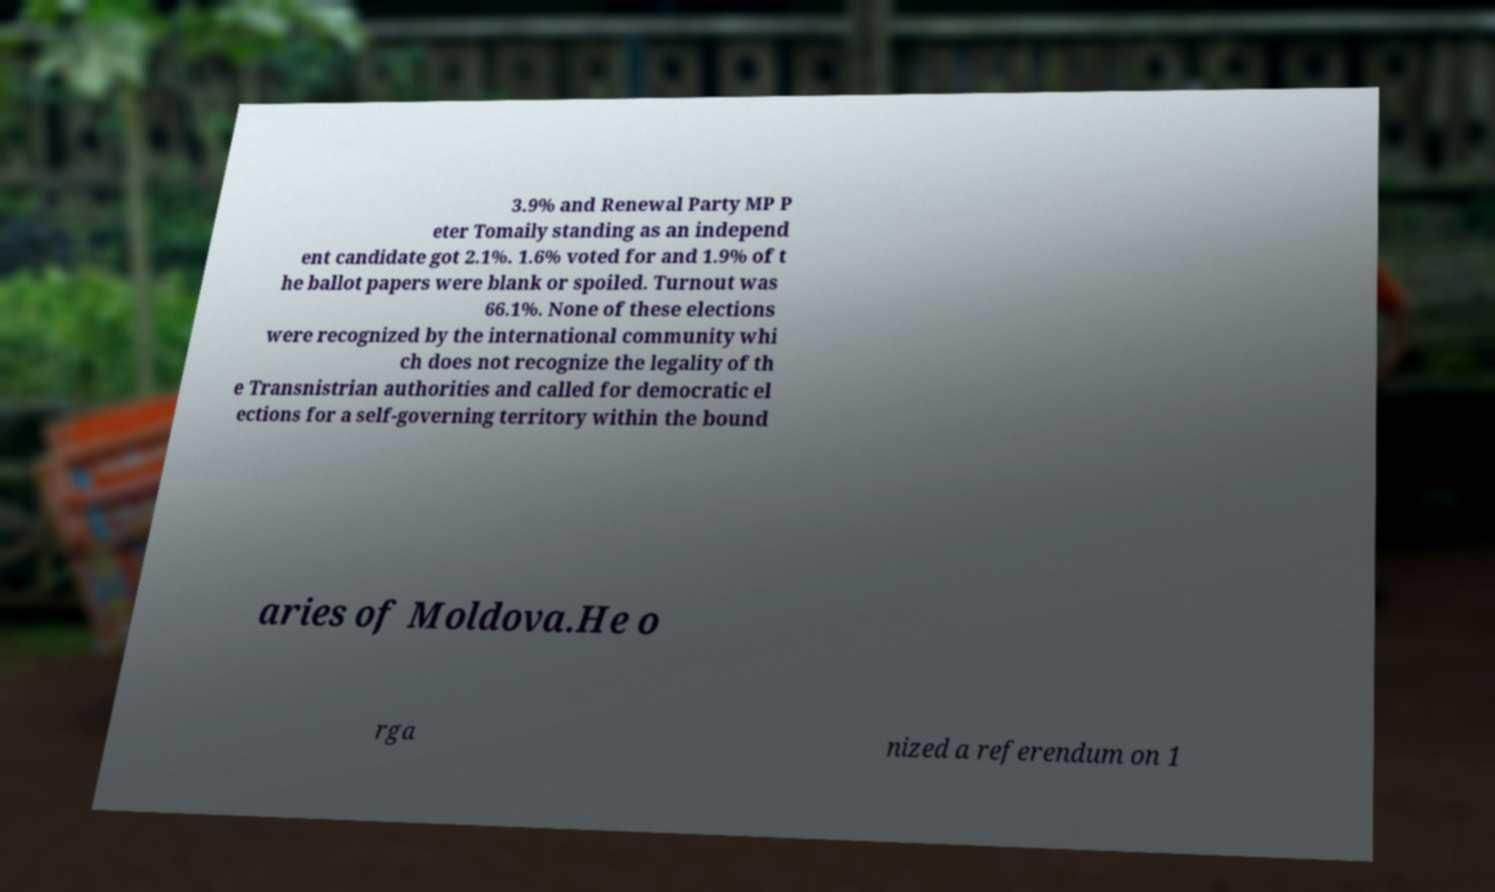Can you accurately transcribe the text from the provided image for me? 3.9% and Renewal Party MP P eter Tomaily standing as an independ ent candidate got 2.1%. 1.6% voted for and 1.9% of t he ballot papers were blank or spoiled. Turnout was 66.1%. None of these elections were recognized by the international community whi ch does not recognize the legality of th e Transnistrian authorities and called for democratic el ections for a self-governing territory within the bound aries of Moldova.He o rga nized a referendum on 1 